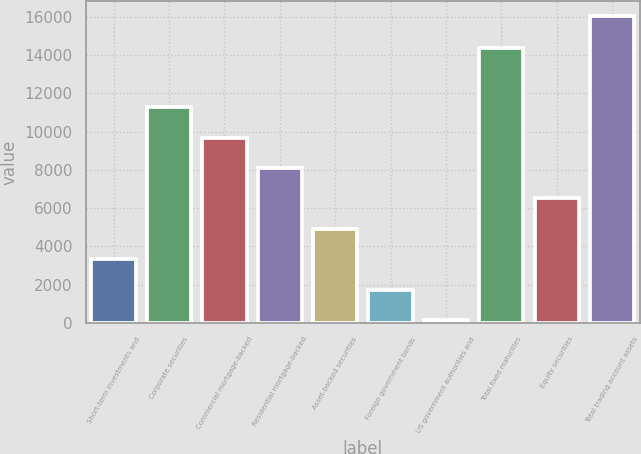Convert chart to OTSL. <chart><loc_0><loc_0><loc_500><loc_500><bar_chart><fcel>Short-term investments and<fcel>Corporate securities<fcel>Commercial mortgage-backed<fcel>Residential mortgage-backed<fcel>Asset-backed securities<fcel>Foreign government bonds<fcel>US government authorities and<fcel>Total fixed maturities<fcel>Equity securities<fcel>Total trading account assets<nl><fcel>3331.2<fcel>11261.7<fcel>9675.6<fcel>8089.5<fcel>4917.3<fcel>1745.1<fcel>159<fcel>14360<fcel>6503.4<fcel>16020<nl></chart> 